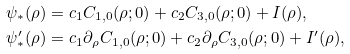<formula> <loc_0><loc_0><loc_500><loc_500>\psi _ { \ast } ( \rho ) & = c _ { 1 } C _ { 1 , 0 } ( \rho ; 0 ) + c _ { 2 } C _ { 3 , 0 } ( \rho ; 0 ) + I ( \rho ) , \\ \psi _ { \ast } ^ { \prime } ( \rho ) & = c _ { 1 } \partial _ { \rho } C _ { 1 , 0 } ( \rho ; 0 ) + c _ { 2 } \partial _ { \rho } C _ { 3 , 0 } ( \rho ; 0 ) + I ^ { \prime } ( \rho ) ,</formula> 